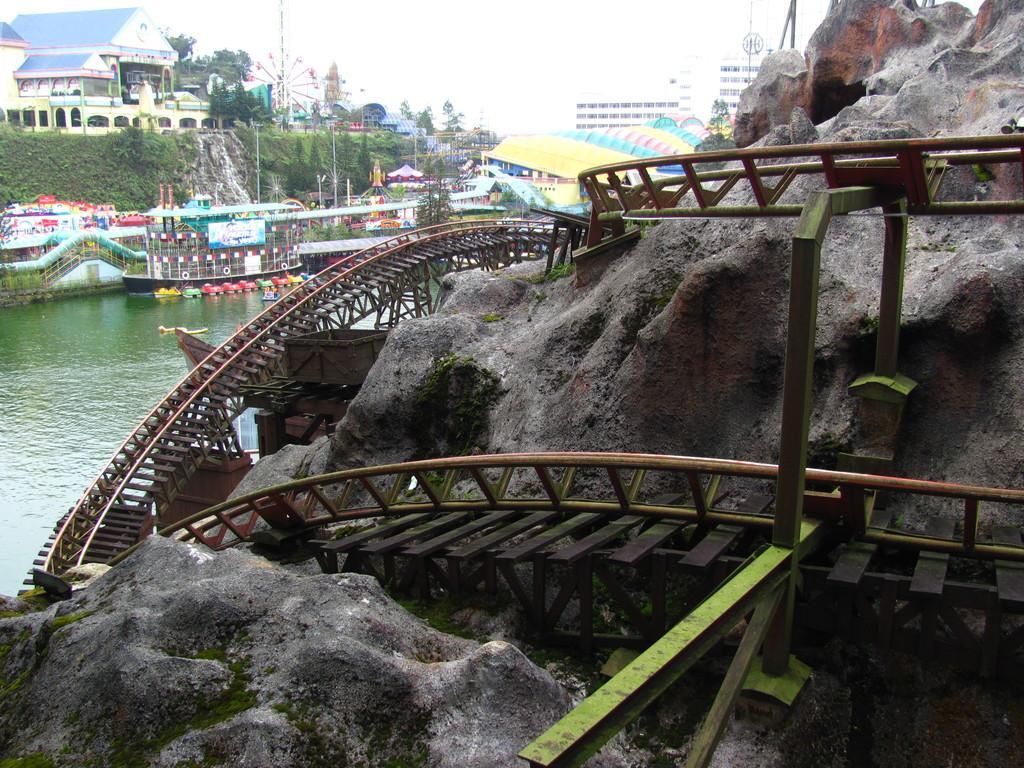Describe this image in one or two sentences. In this image we can see some buildings and we can see the water and the place looks like an amusement park with some rides and we can see a roller coaster track on the rocks. There are some trees and we can see the sky. 